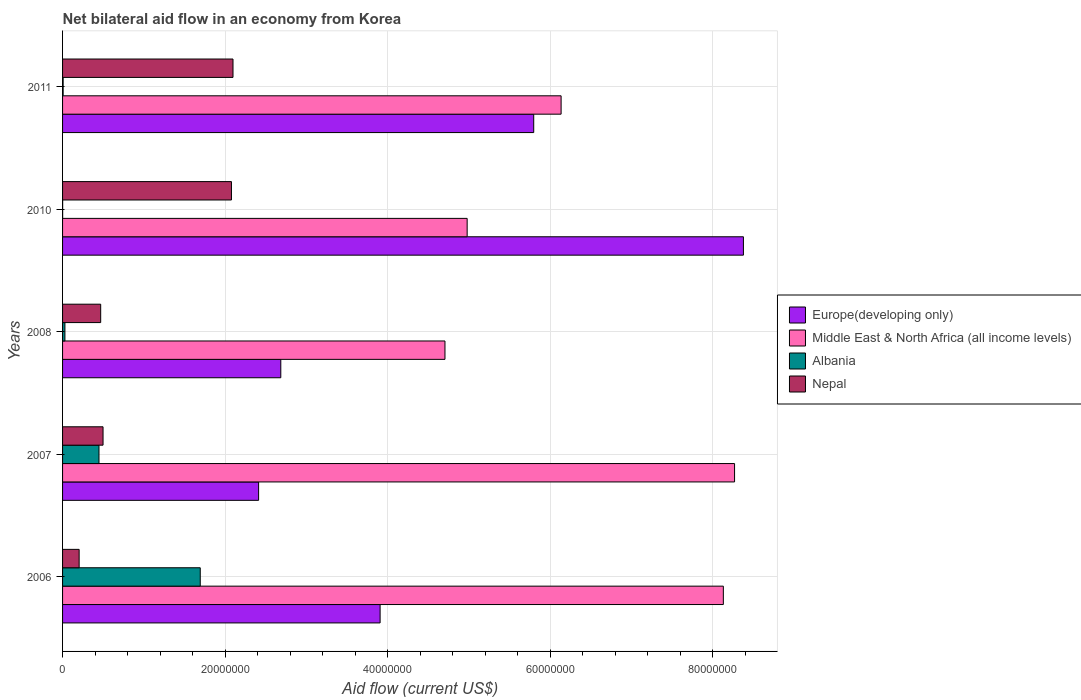How many bars are there on the 2nd tick from the top?
Your response must be concise. 4. What is the label of the 1st group of bars from the top?
Offer a terse response. 2011. What is the net bilateral aid flow in Nepal in 2006?
Offer a very short reply. 2.04e+06. Across all years, what is the maximum net bilateral aid flow in Nepal?
Give a very brief answer. 2.10e+07. Across all years, what is the minimum net bilateral aid flow in Nepal?
Provide a succinct answer. 2.04e+06. In which year was the net bilateral aid flow in Europe(developing only) maximum?
Your answer should be very brief. 2010. What is the total net bilateral aid flow in Albania in the graph?
Your response must be concise. 2.18e+07. What is the difference between the net bilateral aid flow in Albania in 2006 and that in 2011?
Your answer should be very brief. 1.69e+07. What is the difference between the net bilateral aid flow in Europe(developing only) in 2010 and the net bilateral aid flow in Nepal in 2008?
Offer a very short reply. 7.91e+07. What is the average net bilateral aid flow in Nepal per year?
Make the answer very short. 1.07e+07. In the year 2011, what is the difference between the net bilateral aid flow in Albania and net bilateral aid flow in Europe(developing only)?
Your response must be concise. -5.79e+07. What is the ratio of the net bilateral aid flow in Albania in 2006 to that in 2011?
Provide a succinct answer. 242. What is the difference between the highest and the second highest net bilateral aid flow in Middle East & North Africa (all income levels)?
Make the answer very short. 1.38e+06. What is the difference between the highest and the lowest net bilateral aid flow in Nepal?
Make the answer very short. 1.89e+07. Is the sum of the net bilateral aid flow in Nepal in 2006 and 2007 greater than the maximum net bilateral aid flow in Middle East & North Africa (all income levels) across all years?
Offer a terse response. No. Is it the case that in every year, the sum of the net bilateral aid flow in Europe(developing only) and net bilateral aid flow in Middle East & North Africa (all income levels) is greater than the sum of net bilateral aid flow in Nepal and net bilateral aid flow in Albania?
Keep it short and to the point. No. What does the 1st bar from the top in 2008 represents?
Make the answer very short. Nepal. What does the 2nd bar from the bottom in 2007 represents?
Make the answer very short. Middle East & North Africa (all income levels). Are all the bars in the graph horizontal?
Make the answer very short. Yes. How many years are there in the graph?
Give a very brief answer. 5. Are the values on the major ticks of X-axis written in scientific E-notation?
Provide a short and direct response. No. Does the graph contain any zero values?
Give a very brief answer. No. How are the legend labels stacked?
Offer a terse response. Vertical. What is the title of the graph?
Make the answer very short. Net bilateral aid flow in an economy from Korea. What is the label or title of the X-axis?
Provide a short and direct response. Aid flow (current US$). What is the Aid flow (current US$) of Europe(developing only) in 2006?
Keep it short and to the point. 3.91e+07. What is the Aid flow (current US$) in Middle East & North Africa (all income levels) in 2006?
Give a very brief answer. 8.13e+07. What is the Aid flow (current US$) of Albania in 2006?
Provide a succinct answer. 1.69e+07. What is the Aid flow (current US$) of Nepal in 2006?
Offer a very short reply. 2.04e+06. What is the Aid flow (current US$) in Europe(developing only) in 2007?
Offer a terse response. 2.41e+07. What is the Aid flow (current US$) of Middle East & North Africa (all income levels) in 2007?
Provide a succinct answer. 8.27e+07. What is the Aid flow (current US$) in Albania in 2007?
Give a very brief answer. 4.48e+06. What is the Aid flow (current US$) in Nepal in 2007?
Your answer should be compact. 4.98e+06. What is the Aid flow (current US$) in Europe(developing only) in 2008?
Give a very brief answer. 2.68e+07. What is the Aid flow (current US$) in Middle East & North Africa (all income levels) in 2008?
Your answer should be compact. 4.70e+07. What is the Aid flow (current US$) of Nepal in 2008?
Offer a terse response. 4.69e+06. What is the Aid flow (current US$) of Europe(developing only) in 2010?
Provide a short and direct response. 8.38e+07. What is the Aid flow (current US$) of Middle East & North Africa (all income levels) in 2010?
Offer a terse response. 4.98e+07. What is the Aid flow (current US$) in Nepal in 2010?
Make the answer very short. 2.08e+07. What is the Aid flow (current US$) in Europe(developing only) in 2011?
Offer a very short reply. 5.80e+07. What is the Aid flow (current US$) in Middle East & North Africa (all income levels) in 2011?
Offer a terse response. 6.13e+07. What is the Aid flow (current US$) in Nepal in 2011?
Your response must be concise. 2.10e+07. Across all years, what is the maximum Aid flow (current US$) of Europe(developing only)?
Give a very brief answer. 8.38e+07. Across all years, what is the maximum Aid flow (current US$) of Middle East & North Africa (all income levels)?
Ensure brevity in your answer.  8.27e+07. Across all years, what is the maximum Aid flow (current US$) of Albania?
Provide a short and direct response. 1.69e+07. Across all years, what is the maximum Aid flow (current US$) of Nepal?
Ensure brevity in your answer.  2.10e+07. Across all years, what is the minimum Aid flow (current US$) in Europe(developing only)?
Your answer should be very brief. 2.41e+07. Across all years, what is the minimum Aid flow (current US$) of Middle East & North Africa (all income levels)?
Your answer should be compact. 4.70e+07. Across all years, what is the minimum Aid flow (current US$) in Albania?
Offer a terse response. 10000. Across all years, what is the minimum Aid flow (current US$) in Nepal?
Your answer should be compact. 2.04e+06. What is the total Aid flow (current US$) in Europe(developing only) in the graph?
Make the answer very short. 2.32e+08. What is the total Aid flow (current US$) of Middle East & North Africa (all income levels) in the graph?
Your answer should be compact. 3.22e+08. What is the total Aid flow (current US$) in Albania in the graph?
Make the answer very short. 2.18e+07. What is the total Aid flow (current US$) of Nepal in the graph?
Provide a short and direct response. 5.35e+07. What is the difference between the Aid flow (current US$) in Europe(developing only) in 2006 and that in 2007?
Ensure brevity in your answer.  1.50e+07. What is the difference between the Aid flow (current US$) of Middle East & North Africa (all income levels) in 2006 and that in 2007?
Provide a short and direct response. -1.38e+06. What is the difference between the Aid flow (current US$) of Albania in 2006 and that in 2007?
Keep it short and to the point. 1.25e+07. What is the difference between the Aid flow (current US$) of Nepal in 2006 and that in 2007?
Make the answer very short. -2.94e+06. What is the difference between the Aid flow (current US$) of Europe(developing only) in 2006 and that in 2008?
Your answer should be very brief. 1.22e+07. What is the difference between the Aid flow (current US$) of Middle East & North Africa (all income levels) in 2006 and that in 2008?
Your answer should be compact. 3.42e+07. What is the difference between the Aid flow (current US$) in Albania in 2006 and that in 2008?
Your answer should be compact. 1.66e+07. What is the difference between the Aid flow (current US$) of Nepal in 2006 and that in 2008?
Give a very brief answer. -2.65e+06. What is the difference between the Aid flow (current US$) in Europe(developing only) in 2006 and that in 2010?
Ensure brevity in your answer.  -4.47e+07. What is the difference between the Aid flow (current US$) of Middle East & North Africa (all income levels) in 2006 and that in 2010?
Provide a succinct answer. 3.15e+07. What is the difference between the Aid flow (current US$) in Albania in 2006 and that in 2010?
Keep it short and to the point. 1.69e+07. What is the difference between the Aid flow (current US$) of Nepal in 2006 and that in 2010?
Offer a terse response. -1.87e+07. What is the difference between the Aid flow (current US$) in Europe(developing only) in 2006 and that in 2011?
Offer a terse response. -1.89e+07. What is the difference between the Aid flow (current US$) in Middle East & North Africa (all income levels) in 2006 and that in 2011?
Provide a succinct answer. 2.00e+07. What is the difference between the Aid flow (current US$) in Albania in 2006 and that in 2011?
Your answer should be very brief. 1.69e+07. What is the difference between the Aid flow (current US$) in Nepal in 2006 and that in 2011?
Your answer should be very brief. -1.89e+07. What is the difference between the Aid flow (current US$) in Europe(developing only) in 2007 and that in 2008?
Provide a short and direct response. -2.73e+06. What is the difference between the Aid flow (current US$) of Middle East & North Africa (all income levels) in 2007 and that in 2008?
Give a very brief answer. 3.56e+07. What is the difference between the Aid flow (current US$) of Albania in 2007 and that in 2008?
Ensure brevity in your answer.  4.19e+06. What is the difference between the Aid flow (current US$) of Nepal in 2007 and that in 2008?
Make the answer very short. 2.90e+05. What is the difference between the Aid flow (current US$) of Europe(developing only) in 2007 and that in 2010?
Your response must be concise. -5.96e+07. What is the difference between the Aid flow (current US$) of Middle East & North Africa (all income levels) in 2007 and that in 2010?
Give a very brief answer. 3.29e+07. What is the difference between the Aid flow (current US$) in Albania in 2007 and that in 2010?
Give a very brief answer. 4.47e+06. What is the difference between the Aid flow (current US$) of Nepal in 2007 and that in 2010?
Make the answer very short. -1.58e+07. What is the difference between the Aid flow (current US$) in Europe(developing only) in 2007 and that in 2011?
Give a very brief answer. -3.38e+07. What is the difference between the Aid flow (current US$) of Middle East & North Africa (all income levels) in 2007 and that in 2011?
Provide a succinct answer. 2.13e+07. What is the difference between the Aid flow (current US$) of Albania in 2007 and that in 2011?
Ensure brevity in your answer.  4.41e+06. What is the difference between the Aid flow (current US$) of Nepal in 2007 and that in 2011?
Your answer should be very brief. -1.60e+07. What is the difference between the Aid flow (current US$) in Europe(developing only) in 2008 and that in 2010?
Provide a succinct answer. -5.69e+07. What is the difference between the Aid flow (current US$) of Middle East & North Africa (all income levels) in 2008 and that in 2010?
Your answer should be compact. -2.73e+06. What is the difference between the Aid flow (current US$) in Nepal in 2008 and that in 2010?
Ensure brevity in your answer.  -1.61e+07. What is the difference between the Aid flow (current US$) of Europe(developing only) in 2008 and that in 2011?
Make the answer very short. -3.11e+07. What is the difference between the Aid flow (current US$) in Middle East & North Africa (all income levels) in 2008 and that in 2011?
Give a very brief answer. -1.43e+07. What is the difference between the Aid flow (current US$) in Albania in 2008 and that in 2011?
Offer a terse response. 2.20e+05. What is the difference between the Aid flow (current US$) in Nepal in 2008 and that in 2011?
Your answer should be very brief. -1.63e+07. What is the difference between the Aid flow (current US$) of Europe(developing only) in 2010 and that in 2011?
Your response must be concise. 2.58e+07. What is the difference between the Aid flow (current US$) of Middle East & North Africa (all income levels) in 2010 and that in 2011?
Offer a terse response. -1.16e+07. What is the difference between the Aid flow (current US$) in Nepal in 2010 and that in 2011?
Offer a very short reply. -1.90e+05. What is the difference between the Aid flow (current US$) of Europe(developing only) in 2006 and the Aid flow (current US$) of Middle East & North Africa (all income levels) in 2007?
Your response must be concise. -4.36e+07. What is the difference between the Aid flow (current US$) of Europe(developing only) in 2006 and the Aid flow (current US$) of Albania in 2007?
Make the answer very short. 3.46e+07. What is the difference between the Aid flow (current US$) of Europe(developing only) in 2006 and the Aid flow (current US$) of Nepal in 2007?
Your answer should be very brief. 3.41e+07. What is the difference between the Aid flow (current US$) in Middle East & North Africa (all income levels) in 2006 and the Aid flow (current US$) in Albania in 2007?
Offer a very short reply. 7.68e+07. What is the difference between the Aid flow (current US$) in Middle East & North Africa (all income levels) in 2006 and the Aid flow (current US$) in Nepal in 2007?
Provide a short and direct response. 7.63e+07. What is the difference between the Aid flow (current US$) of Albania in 2006 and the Aid flow (current US$) of Nepal in 2007?
Offer a very short reply. 1.20e+07. What is the difference between the Aid flow (current US$) in Europe(developing only) in 2006 and the Aid flow (current US$) in Middle East & North Africa (all income levels) in 2008?
Give a very brief answer. -7.98e+06. What is the difference between the Aid flow (current US$) of Europe(developing only) in 2006 and the Aid flow (current US$) of Albania in 2008?
Provide a short and direct response. 3.88e+07. What is the difference between the Aid flow (current US$) of Europe(developing only) in 2006 and the Aid flow (current US$) of Nepal in 2008?
Ensure brevity in your answer.  3.44e+07. What is the difference between the Aid flow (current US$) in Middle East & North Africa (all income levels) in 2006 and the Aid flow (current US$) in Albania in 2008?
Give a very brief answer. 8.10e+07. What is the difference between the Aid flow (current US$) of Middle East & North Africa (all income levels) in 2006 and the Aid flow (current US$) of Nepal in 2008?
Offer a terse response. 7.66e+07. What is the difference between the Aid flow (current US$) in Albania in 2006 and the Aid flow (current US$) in Nepal in 2008?
Your answer should be very brief. 1.22e+07. What is the difference between the Aid flow (current US$) in Europe(developing only) in 2006 and the Aid flow (current US$) in Middle East & North Africa (all income levels) in 2010?
Keep it short and to the point. -1.07e+07. What is the difference between the Aid flow (current US$) in Europe(developing only) in 2006 and the Aid flow (current US$) in Albania in 2010?
Give a very brief answer. 3.91e+07. What is the difference between the Aid flow (current US$) in Europe(developing only) in 2006 and the Aid flow (current US$) in Nepal in 2010?
Your answer should be very brief. 1.83e+07. What is the difference between the Aid flow (current US$) of Middle East & North Africa (all income levels) in 2006 and the Aid flow (current US$) of Albania in 2010?
Give a very brief answer. 8.13e+07. What is the difference between the Aid flow (current US$) of Middle East & North Africa (all income levels) in 2006 and the Aid flow (current US$) of Nepal in 2010?
Offer a terse response. 6.05e+07. What is the difference between the Aid flow (current US$) of Albania in 2006 and the Aid flow (current US$) of Nepal in 2010?
Offer a terse response. -3.84e+06. What is the difference between the Aid flow (current US$) of Europe(developing only) in 2006 and the Aid flow (current US$) of Middle East & North Africa (all income levels) in 2011?
Offer a terse response. -2.23e+07. What is the difference between the Aid flow (current US$) of Europe(developing only) in 2006 and the Aid flow (current US$) of Albania in 2011?
Give a very brief answer. 3.90e+07. What is the difference between the Aid flow (current US$) in Europe(developing only) in 2006 and the Aid flow (current US$) in Nepal in 2011?
Give a very brief answer. 1.81e+07. What is the difference between the Aid flow (current US$) in Middle East & North Africa (all income levels) in 2006 and the Aid flow (current US$) in Albania in 2011?
Ensure brevity in your answer.  8.12e+07. What is the difference between the Aid flow (current US$) of Middle East & North Africa (all income levels) in 2006 and the Aid flow (current US$) of Nepal in 2011?
Keep it short and to the point. 6.03e+07. What is the difference between the Aid flow (current US$) in Albania in 2006 and the Aid flow (current US$) in Nepal in 2011?
Provide a short and direct response. -4.03e+06. What is the difference between the Aid flow (current US$) of Europe(developing only) in 2007 and the Aid flow (current US$) of Middle East & North Africa (all income levels) in 2008?
Your answer should be compact. -2.29e+07. What is the difference between the Aid flow (current US$) in Europe(developing only) in 2007 and the Aid flow (current US$) in Albania in 2008?
Provide a succinct answer. 2.38e+07. What is the difference between the Aid flow (current US$) in Europe(developing only) in 2007 and the Aid flow (current US$) in Nepal in 2008?
Offer a terse response. 1.94e+07. What is the difference between the Aid flow (current US$) of Middle East & North Africa (all income levels) in 2007 and the Aid flow (current US$) of Albania in 2008?
Ensure brevity in your answer.  8.24e+07. What is the difference between the Aid flow (current US$) of Middle East & North Africa (all income levels) in 2007 and the Aid flow (current US$) of Nepal in 2008?
Offer a terse response. 7.80e+07. What is the difference between the Aid flow (current US$) of Europe(developing only) in 2007 and the Aid flow (current US$) of Middle East & North Africa (all income levels) in 2010?
Make the answer very short. -2.57e+07. What is the difference between the Aid flow (current US$) of Europe(developing only) in 2007 and the Aid flow (current US$) of Albania in 2010?
Ensure brevity in your answer.  2.41e+07. What is the difference between the Aid flow (current US$) in Europe(developing only) in 2007 and the Aid flow (current US$) in Nepal in 2010?
Your answer should be very brief. 3.34e+06. What is the difference between the Aid flow (current US$) of Middle East & North Africa (all income levels) in 2007 and the Aid flow (current US$) of Albania in 2010?
Your response must be concise. 8.27e+07. What is the difference between the Aid flow (current US$) in Middle East & North Africa (all income levels) in 2007 and the Aid flow (current US$) in Nepal in 2010?
Your answer should be compact. 6.19e+07. What is the difference between the Aid flow (current US$) in Albania in 2007 and the Aid flow (current US$) in Nepal in 2010?
Give a very brief answer. -1.63e+07. What is the difference between the Aid flow (current US$) of Europe(developing only) in 2007 and the Aid flow (current US$) of Middle East & North Africa (all income levels) in 2011?
Keep it short and to the point. -3.72e+07. What is the difference between the Aid flow (current US$) in Europe(developing only) in 2007 and the Aid flow (current US$) in Albania in 2011?
Provide a short and direct response. 2.40e+07. What is the difference between the Aid flow (current US$) of Europe(developing only) in 2007 and the Aid flow (current US$) of Nepal in 2011?
Give a very brief answer. 3.15e+06. What is the difference between the Aid flow (current US$) in Middle East & North Africa (all income levels) in 2007 and the Aid flow (current US$) in Albania in 2011?
Provide a short and direct response. 8.26e+07. What is the difference between the Aid flow (current US$) in Middle East & North Africa (all income levels) in 2007 and the Aid flow (current US$) in Nepal in 2011?
Make the answer very short. 6.17e+07. What is the difference between the Aid flow (current US$) in Albania in 2007 and the Aid flow (current US$) in Nepal in 2011?
Your answer should be compact. -1.65e+07. What is the difference between the Aid flow (current US$) in Europe(developing only) in 2008 and the Aid flow (current US$) in Middle East & North Africa (all income levels) in 2010?
Offer a very short reply. -2.29e+07. What is the difference between the Aid flow (current US$) of Europe(developing only) in 2008 and the Aid flow (current US$) of Albania in 2010?
Ensure brevity in your answer.  2.68e+07. What is the difference between the Aid flow (current US$) in Europe(developing only) in 2008 and the Aid flow (current US$) in Nepal in 2010?
Provide a succinct answer. 6.07e+06. What is the difference between the Aid flow (current US$) in Middle East & North Africa (all income levels) in 2008 and the Aid flow (current US$) in Albania in 2010?
Keep it short and to the point. 4.70e+07. What is the difference between the Aid flow (current US$) of Middle East & North Africa (all income levels) in 2008 and the Aid flow (current US$) of Nepal in 2010?
Provide a succinct answer. 2.63e+07. What is the difference between the Aid flow (current US$) of Albania in 2008 and the Aid flow (current US$) of Nepal in 2010?
Keep it short and to the point. -2.05e+07. What is the difference between the Aid flow (current US$) of Europe(developing only) in 2008 and the Aid flow (current US$) of Middle East & North Africa (all income levels) in 2011?
Your response must be concise. -3.45e+07. What is the difference between the Aid flow (current US$) of Europe(developing only) in 2008 and the Aid flow (current US$) of Albania in 2011?
Offer a terse response. 2.68e+07. What is the difference between the Aid flow (current US$) in Europe(developing only) in 2008 and the Aid flow (current US$) in Nepal in 2011?
Your answer should be very brief. 5.88e+06. What is the difference between the Aid flow (current US$) of Middle East & North Africa (all income levels) in 2008 and the Aid flow (current US$) of Albania in 2011?
Offer a terse response. 4.70e+07. What is the difference between the Aid flow (current US$) in Middle East & North Africa (all income levels) in 2008 and the Aid flow (current US$) in Nepal in 2011?
Give a very brief answer. 2.61e+07. What is the difference between the Aid flow (current US$) of Albania in 2008 and the Aid flow (current US$) of Nepal in 2011?
Your response must be concise. -2.07e+07. What is the difference between the Aid flow (current US$) in Europe(developing only) in 2010 and the Aid flow (current US$) in Middle East & North Africa (all income levels) in 2011?
Provide a succinct answer. 2.24e+07. What is the difference between the Aid flow (current US$) in Europe(developing only) in 2010 and the Aid flow (current US$) in Albania in 2011?
Make the answer very short. 8.37e+07. What is the difference between the Aid flow (current US$) of Europe(developing only) in 2010 and the Aid flow (current US$) of Nepal in 2011?
Give a very brief answer. 6.28e+07. What is the difference between the Aid flow (current US$) in Middle East & North Africa (all income levels) in 2010 and the Aid flow (current US$) in Albania in 2011?
Ensure brevity in your answer.  4.97e+07. What is the difference between the Aid flow (current US$) of Middle East & North Africa (all income levels) in 2010 and the Aid flow (current US$) of Nepal in 2011?
Offer a very short reply. 2.88e+07. What is the difference between the Aid flow (current US$) of Albania in 2010 and the Aid flow (current US$) of Nepal in 2011?
Offer a very short reply. -2.10e+07. What is the average Aid flow (current US$) in Europe(developing only) per year?
Your answer should be compact. 4.64e+07. What is the average Aid flow (current US$) in Middle East & North Africa (all income levels) per year?
Keep it short and to the point. 6.44e+07. What is the average Aid flow (current US$) in Albania per year?
Your answer should be very brief. 4.36e+06. What is the average Aid flow (current US$) in Nepal per year?
Your answer should be compact. 1.07e+07. In the year 2006, what is the difference between the Aid flow (current US$) in Europe(developing only) and Aid flow (current US$) in Middle East & North Africa (all income levels)?
Your response must be concise. -4.22e+07. In the year 2006, what is the difference between the Aid flow (current US$) in Europe(developing only) and Aid flow (current US$) in Albania?
Keep it short and to the point. 2.21e+07. In the year 2006, what is the difference between the Aid flow (current US$) of Europe(developing only) and Aid flow (current US$) of Nepal?
Your answer should be very brief. 3.70e+07. In the year 2006, what is the difference between the Aid flow (current US$) in Middle East & North Africa (all income levels) and Aid flow (current US$) in Albania?
Your answer should be compact. 6.44e+07. In the year 2006, what is the difference between the Aid flow (current US$) in Middle East & North Africa (all income levels) and Aid flow (current US$) in Nepal?
Ensure brevity in your answer.  7.93e+07. In the year 2006, what is the difference between the Aid flow (current US$) in Albania and Aid flow (current US$) in Nepal?
Your answer should be very brief. 1.49e+07. In the year 2007, what is the difference between the Aid flow (current US$) in Europe(developing only) and Aid flow (current US$) in Middle East & North Africa (all income levels)?
Your answer should be very brief. -5.86e+07. In the year 2007, what is the difference between the Aid flow (current US$) in Europe(developing only) and Aid flow (current US$) in Albania?
Provide a succinct answer. 1.96e+07. In the year 2007, what is the difference between the Aid flow (current US$) in Europe(developing only) and Aid flow (current US$) in Nepal?
Provide a short and direct response. 1.91e+07. In the year 2007, what is the difference between the Aid flow (current US$) in Middle East & North Africa (all income levels) and Aid flow (current US$) in Albania?
Provide a short and direct response. 7.82e+07. In the year 2007, what is the difference between the Aid flow (current US$) in Middle East & North Africa (all income levels) and Aid flow (current US$) in Nepal?
Provide a short and direct response. 7.77e+07. In the year 2007, what is the difference between the Aid flow (current US$) of Albania and Aid flow (current US$) of Nepal?
Your response must be concise. -5.00e+05. In the year 2008, what is the difference between the Aid flow (current US$) of Europe(developing only) and Aid flow (current US$) of Middle East & North Africa (all income levels)?
Keep it short and to the point. -2.02e+07. In the year 2008, what is the difference between the Aid flow (current US$) in Europe(developing only) and Aid flow (current US$) in Albania?
Make the answer very short. 2.66e+07. In the year 2008, what is the difference between the Aid flow (current US$) in Europe(developing only) and Aid flow (current US$) in Nepal?
Provide a short and direct response. 2.22e+07. In the year 2008, what is the difference between the Aid flow (current US$) of Middle East & North Africa (all income levels) and Aid flow (current US$) of Albania?
Provide a succinct answer. 4.68e+07. In the year 2008, what is the difference between the Aid flow (current US$) of Middle East & North Africa (all income levels) and Aid flow (current US$) of Nepal?
Provide a short and direct response. 4.24e+07. In the year 2008, what is the difference between the Aid flow (current US$) of Albania and Aid flow (current US$) of Nepal?
Offer a terse response. -4.40e+06. In the year 2010, what is the difference between the Aid flow (current US$) in Europe(developing only) and Aid flow (current US$) in Middle East & North Africa (all income levels)?
Make the answer very short. 3.40e+07. In the year 2010, what is the difference between the Aid flow (current US$) of Europe(developing only) and Aid flow (current US$) of Albania?
Your response must be concise. 8.38e+07. In the year 2010, what is the difference between the Aid flow (current US$) of Europe(developing only) and Aid flow (current US$) of Nepal?
Ensure brevity in your answer.  6.30e+07. In the year 2010, what is the difference between the Aid flow (current US$) in Middle East & North Africa (all income levels) and Aid flow (current US$) in Albania?
Your answer should be very brief. 4.98e+07. In the year 2010, what is the difference between the Aid flow (current US$) in Middle East & North Africa (all income levels) and Aid flow (current US$) in Nepal?
Give a very brief answer. 2.90e+07. In the year 2010, what is the difference between the Aid flow (current US$) of Albania and Aid flow (current US$) of Nepal?
Provide a short and direct response. -2.08e+07. In the year 2011, what is the difference between the Aid flow (current US$) in Europe(developing only) and Aid flow (current US$) in Middle East & North Africa (all income levels)?
Your response must be concise. -3.37e+06. In the year 2011, what is the difference between the Aid flow (current US$) in Europe(developing only) and Aid flow (current US$) in Albania?
Keep it short and to the point. 5.79e+07. In the year 2011, what is the difference between the Aid flow (current US$) of Europe(developing only) and Aid flow (current US$) of Nepal?
Make the answer very short. 3.70e+07. In the year 2011, what is the difference between the Aid flow (current US$) in Middle East & North Africa (all income levels) and Aid flow (current US$) in Albania?
Keep it short and to the point. 6.13e+07. In the year 2011, what is the difference between the Aid flow (current US$) in Middle East & North Africa (all income levels) and Aid flow (current US$) in Nepal?
Provide a short and direct response. 4.04e+07. In the year 2011, what is the difference between the Aid flow (current US$) of Albania and Aid flow (current US$) of Nepal?
Ensure brevity in your answer.  -2.09e+07. What is the ratio of the Aid flow (current US$) of Europe(developing only) in 2006 to that in 2007?
Ensure brevity in your answer.  1.62. What is the ratio of the Aid flow (current US$) of Middle East & North Africa (all income levels) in 2006 to that in 2007?
Your response must be concise. 0.98. What is the ratio of the Aid flow (current US$) in Albania in 2006 to that in 2007?
Provide a succinct answer. 3.78. What is the ratio of the Aid flow (current US$) in Nepal in 2006 to that in 2007?
Make the answer very short. 0.41. What is the ratio of the Aid flow (current US$) of Europe(developing only) in 2006 to that in 2008?
Provide a succinct answer. 1.46. What is the ratio of the Aid flow (current US$) of Middle East & North Africa (all income levels) in 2006 to that in 2008?
Give a very brief answer. 1.73. What is the ratio of the Aid flow (current US$) in Albania in 2006 to that in 2008?
Offer a terse response. 58.41. What is the ratio of the Aid flow (current US$) in Nepal in 2006 to that in 2008?
Provide a succinct answer. 0.43. What is the ratio of the Aid flow (current US$) of Europe(developing only) in 2006 to that in 2010?
Ensure brevity in your answer.  0.47. What is the ratio of the Aid flow (current US$) of Middle East & North Africa (all income levels) in 2006 to that in 2010?
Your response must be concise. 1.63. What is the ratio of the Aid flow (current US$) in Albania in 2006 to that in 2010?
Keep it short and to the point. 1694. What is the ratio of the Aid flow (current US$) in Nepal in 2006 to that in 2010?
Your answer should be very brief. 0.1. What is the ratio of the Aid flow (current US$) in Europe(developing only) in 2006 to that in 2011?
Ensure brevity in your answer.  0.67. What is the ratio of the Aid flow (current US$) in Middle East & North Africa (all income levels) in 2006 to that in 2011?
Offer a terse response. 1.33. What is the ratio of the Aid flow (current US$) in Albania in 2006 to that in 2011?
Provide a short and direct response. 242. What is the ratio of the Aid flow (current US$) of Nepal in 2006 to that in 2011?
Give a very brief answer. 0.1. What is the ratio of the Aid flow (current US$) in Europe(developing only) in 2007 to that in 2008?
Provide a succinct answer. 0.9. What is the ratio of the Aid flow (current US$) in Middle East & North Africa (all income levels) in 2007 to that in 2008?
Provide a short and direct response. 1.76. What is the ratio of the Aid flow (current US$) of Albania in 2007 to that in 2008?
Keep it short and to the point. 15.45. What is the ratio of the Aid flow (current US$) of Nepal in 2007 to that in 2008?
Your answer should be compact. 1.06. What is the ratio of the Aid flow (current US$) in Europe(developing only) in 2007 to that in 2010?
Your response must be concise. 0.29. What is the ratio of the Aid flow (current US$) of Middle East & North Africa (all income levels) in 2007 to that in 2010?
Your answer should be very brief. 1.66. What is the ratio of the Aid flow (current US$) in Albania in 2007 to that in 2010?
Your answer should be compact. 448. What is the ratio of the Aid flow (current US$) of Nepal in 2007 to that in 2010?
Your response must be concise. 0.24. What is the ratio of the Aid flow (current US$) in Europe(developing only) in 2007 to that in 2011?
Provide a succinct answer. 0.42. What is the ratio of the Aid flow (current US$) in Middle East & North Africa (all income levels) in 2007 to that in 2011?
Provide a succinct answer. 1.35. What is the ratio of the Aid flow (current US$) of Nepal in 2007 to that in 2011?
Offer a terse response. 0.24. What is the ratio of the Aid flow (current US$) of Europe(developing only) in 2008 to that in 2010?
Provide a succinct answer. 0.32. What is the ratio of the Aid flow (current US$) of Middle East & North Africa (all income levels) in 2008 to that in 2010?
Offer a terse response. 0.95. What is the ratio of the Aid flow (current US$) of Nepal in 2008 to that in 2010?
Make the answer very short. 0.23. What is the ratio of the Aid flow (current US$) of Europe(developing only) in 2008 to that in 2011?
Provide a short and direct response. 0.46. What is the ratio of the Aid flow (current US$) in Middle East & North Africa (all income levels) in 2008 to that in 2011?
Provide a short and direct response. 0.77. What is the ratio of the Aid flow (current US$) in Albania in 2008 to that in 2011?
Ensure brevity in your answer.  4.14. What is the ratio of the Aid flow (current US$) of Nepal in 2008 to that in 2011?
Your response must be concise. 0.22. What is the ratio of the Aid flow (current US$) of Europe(developing only) in 2010 to that in 2011?
Give a very brief answer. 1.45. What is the ratio of the Aid flow (current US$) of Middle East & North Africa (all income levels) in 2010 to that in 2011?
Your answer should be compact. 0.81. What is the ratio of the Aid flow (current US$) of Albania in 2010 to that in 2011?
Offer a terse response. 0.14. What is the ratio of the Aid flow (current US$) in Nepal in 2010 to that in 2011?
Ensure brevity in your answer.  0.99. What is the difference between the highest and the second highest Aid flow (current US$) in Europe(developing only)?
Provide a short and direct response. 2.58e+07. What is the difference between the highest and the second highest Aid flow (current US$) in Middle East & North Africa (all income levels)?
Provide a succinct answer. 1.38e+06. What is the difference between the highest and the second highest Aid flow (current US$) of Albania?
Your answer should be very brief. 1.25e+07. What is the difference between the highest and the second highest Aid flow (current US$) of Nepal?
Offer a terse response. 1.90e+05. What is the difference between the highest and the lowest Aid flow (current US$) of Europe(developing only)?
Provide a short and direct response. 5.96e+07. What is the difference between the highest and the lowest Aid flow (current US$) of Middle East & North Africa (all income levels)?
Your answer should be compact. 3.56e+07. What is the difference between the highest and the lowest Aid flow (current US$) in Albania?
Offer a very short reply. 1.69e+07. What is the difference between the highest and the lowest Aid flow (current US$) in Nepal?
Your answer should be very brief. 1.89e+07. 